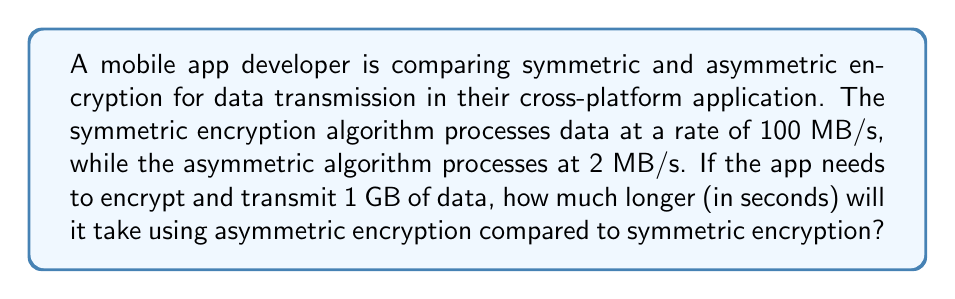Teach me how to tackle this problem. Let's approach this step-by-step:

1) First, we need to convert 1 GB to MB:
   $1 \text{ GB} = 1024 \text{ MB}$

2) Now, let's calculate the time taken for symmetric encryption:
   $$T_{symmetric} = \frac{1024 \text{ MB}}{100 \text{ MB/s}} = 10.24 \text{ seconds}$$

3) Next, let's calculate the time taken for asymmetric encryption:
   $$T_{asymmetric} = \frac{1024 \text{ MB}}{2 \text{ MB/s}} = 512 \text{ seconds}$$

4) To find how much longer asymmetric encryption takes, we subtract:
   $$T_{difference} = T_{asymmetric} - T_{symmetric} = 512 - 10.24 = 501.76 \text{ seconds}$$

Therefore, asymmetric encryption will take 501.76 seconds longer than symmetric encryption for 1 GB of data.
Answer: 501.76 seconds 